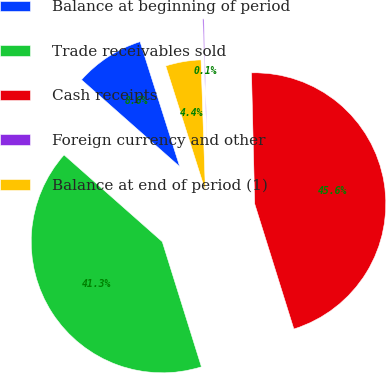Convert chart. <chart><loc_0><loc_0><loc_500><loc_500><pie_chart><fcel>Balance at beginning of period<fcel>Trade receivables sold<fcel>Cash receipts<fcel>Foreign currency and other<fcel>Balance at end of period (1)<nl><fcel>8.59%<fcel>41.35%<fcel>45.57%<fcel>0.14%<fcel>4.36%<nl></chart> 